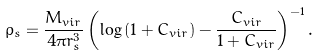Convert formula to latex. <formula><loc_0><loc_0><loc_500><loc_500>\rho _ { s } = \frac { M _ { v i r } } { 4 \pi r _ { s } ^ { 3 } } \left ( \log { ( 1 + C _ { v i r } ) } - \frac { C _ { v i r } } { 1 + C _ { v i r } } \right ) ^ { - 1 } .</formula> 